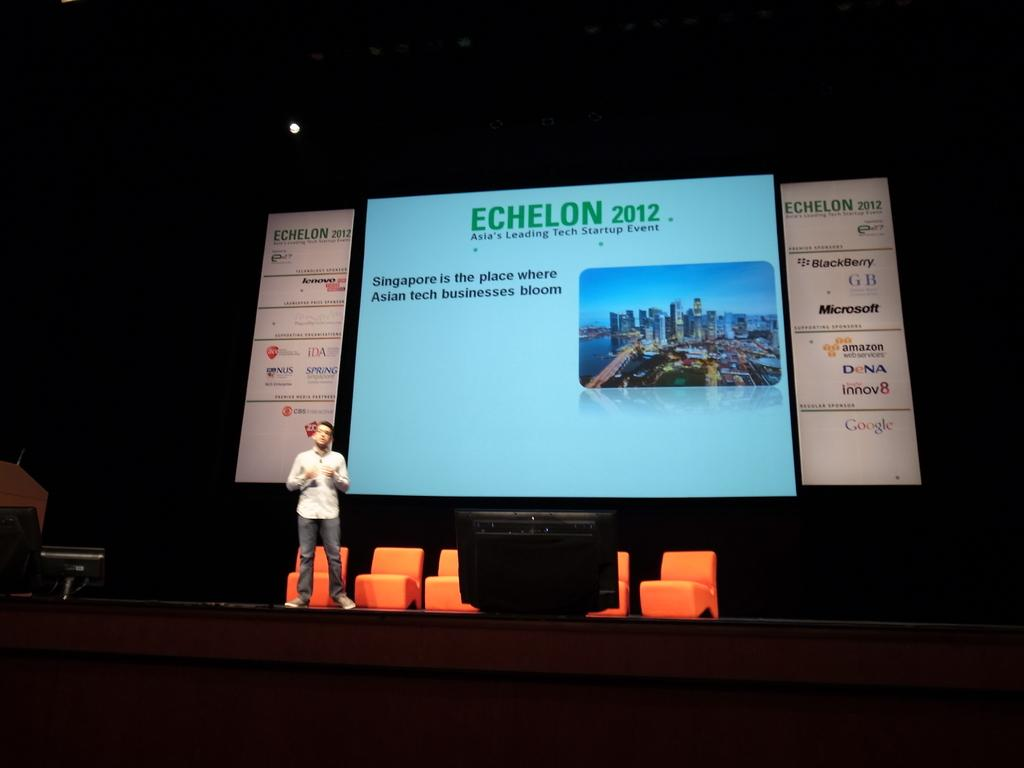<image>
Render a clear and concise summary of the photo. A man stands on a stage in front of a very large screen for an Asian technology event. 